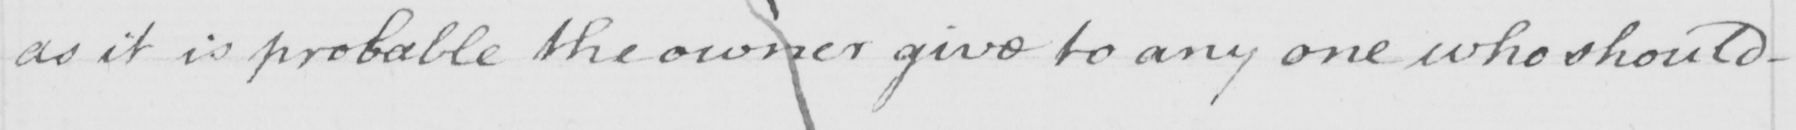Please transcribe the handwritten text in this image. as it is probable the owner give to any one who should 